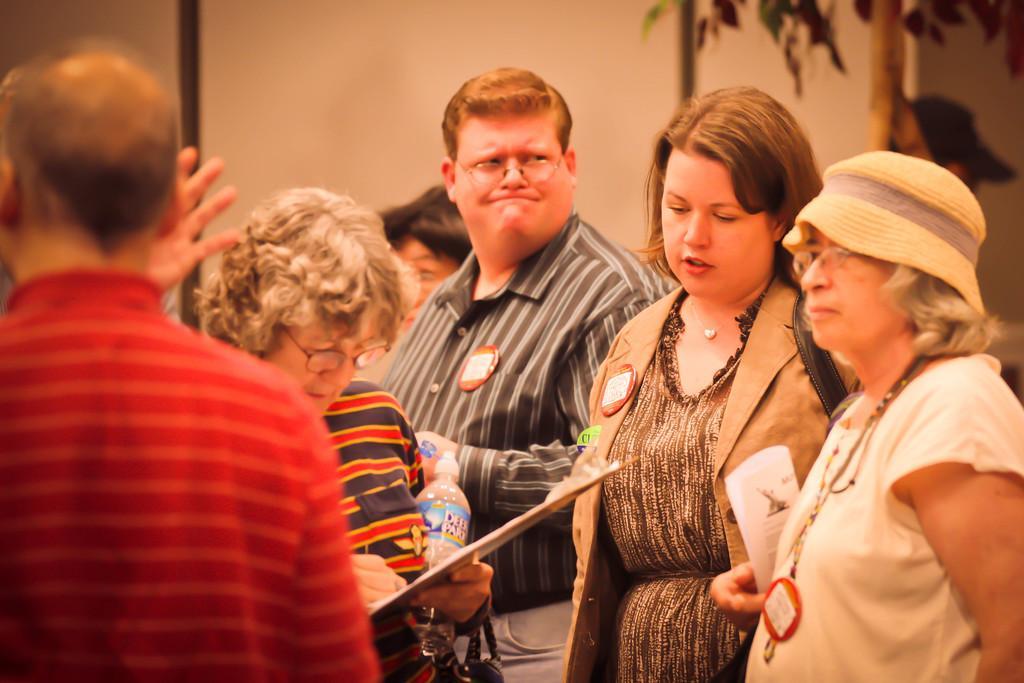Describe this image in one or two sentences. In this image I can see a person wearing red and orange t shirt and a woman wearing white t shirt and hat and other woman wearing brown jacket and black dress and few other persons standing. In the background I can see the white colored wall, few trees and few other persons. 